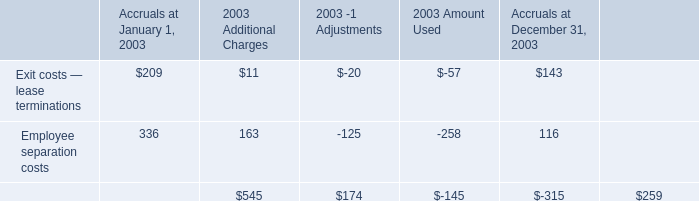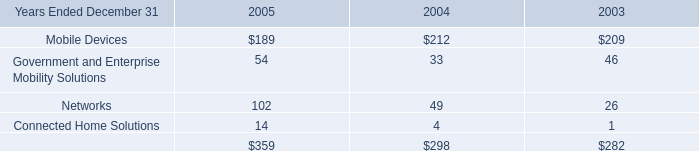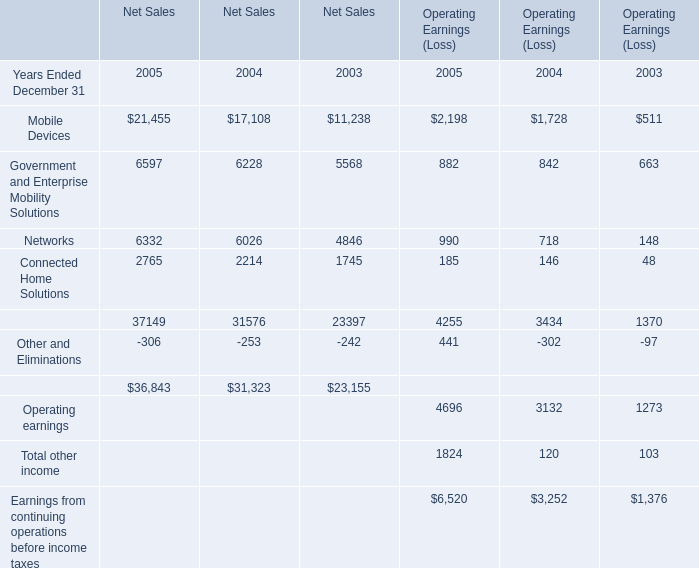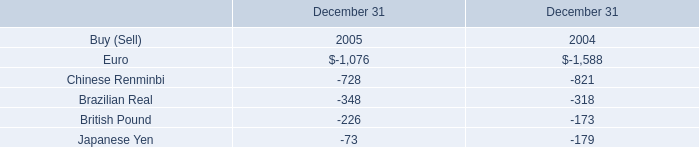What's the sum of Euro of December 31 2004, and Government and Enterprise Mobility Solutions of Net Sales 2004 ? 
Computations: (1588.0 + 6228.0)
Answer: 7816.0. What's the greatest value of Net Sales in 2005? 
Answer: 21455. 